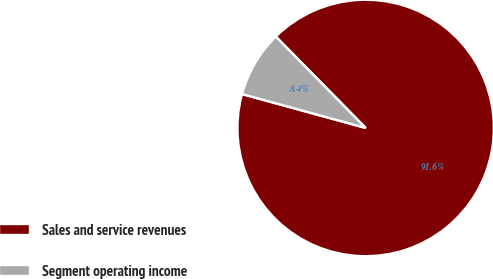Convert chart. <chart><loc_0><loc_0><loc_500><loc_500><pie_chart><fcel>Sales and service revenues<fcel>Segment operating income<nl><fcel>91.63%<fcel>8.37%<nl></chart> 